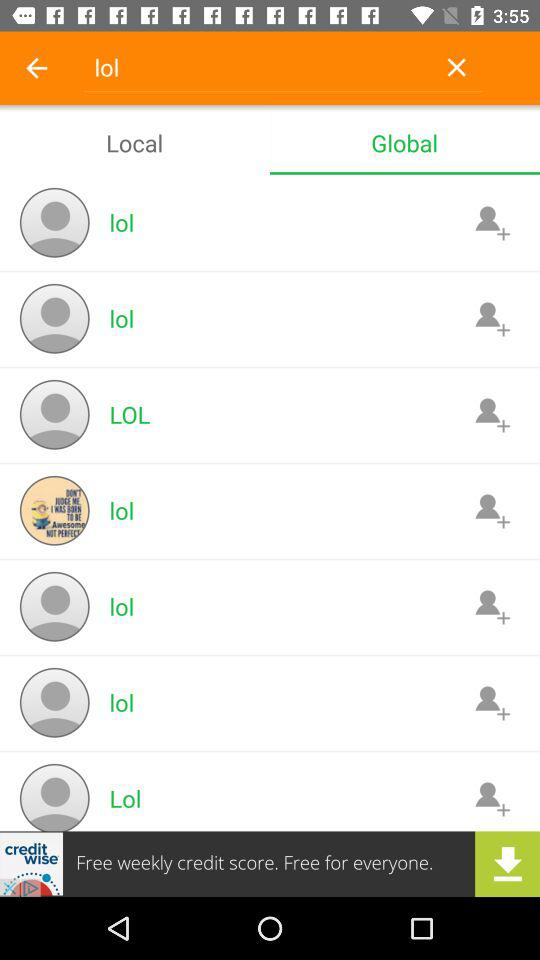What is the input text entered into the search bar? The entered input text is "lol". 